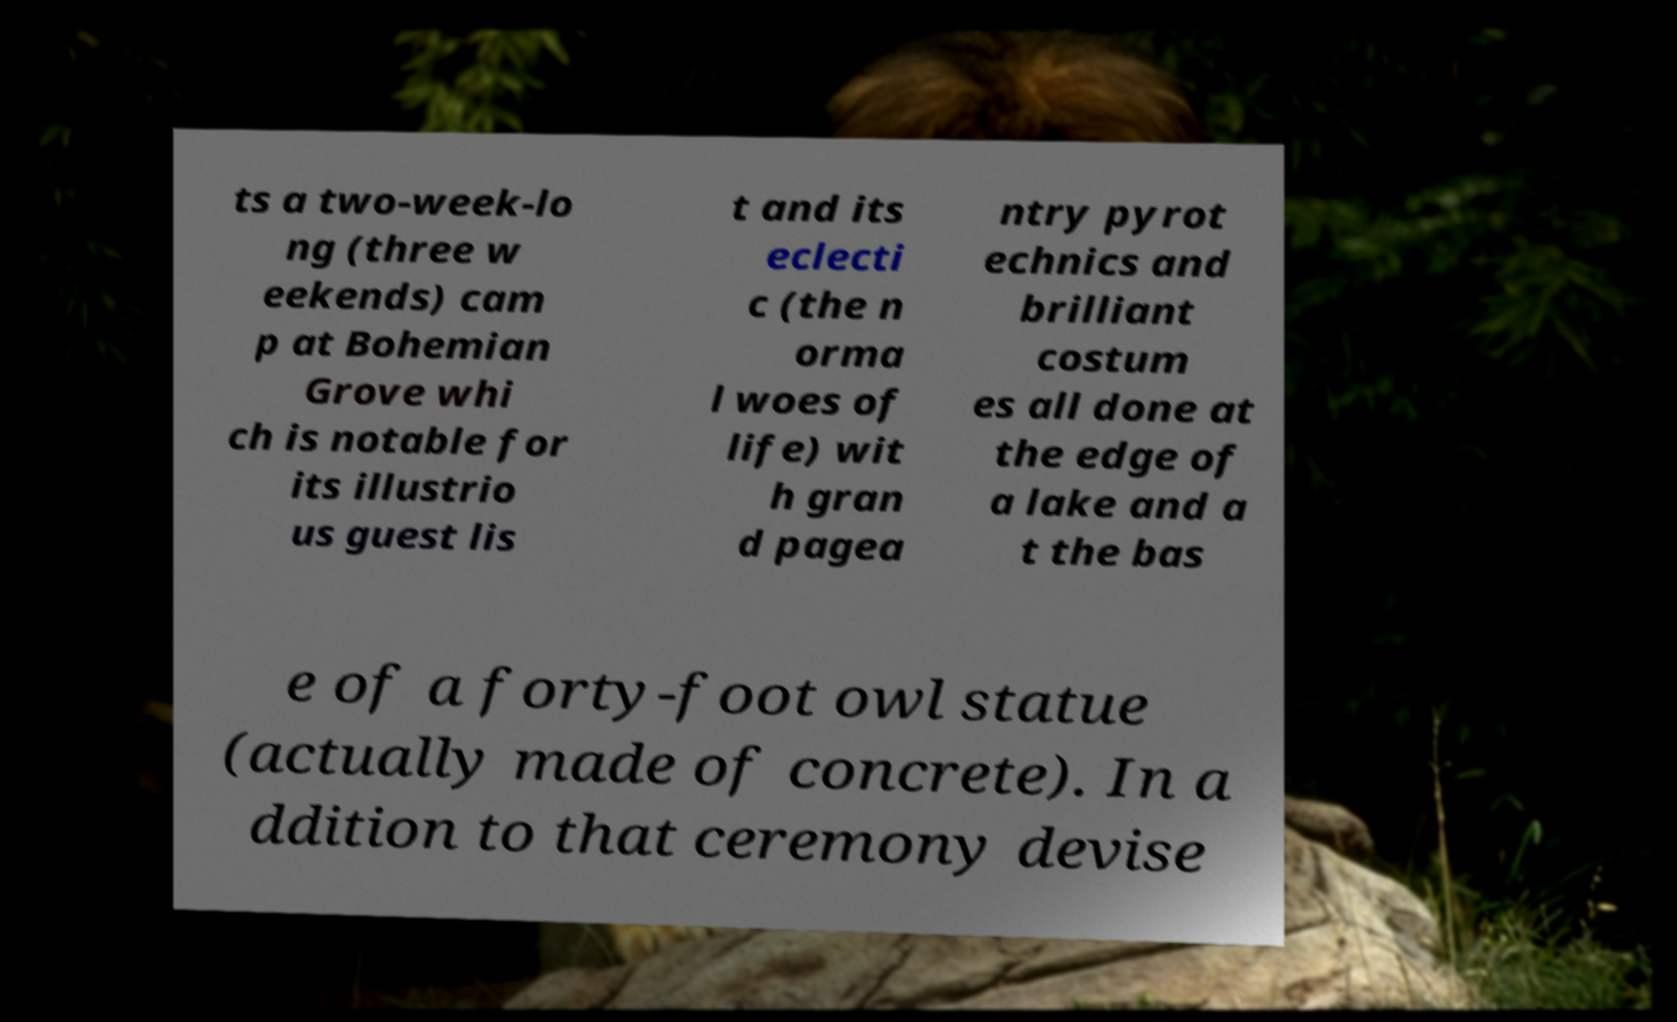For documentation purposes, I need the text within this image transcribed. Could you provide that? ts a two-week-lo ng (three w eekends) cam p at Bohemian Grove whi ch is notable for its illustrio us guest lis t and its eclecti c (the n orma l woes of life) wit h gran d pagea ntry pyrot echnics and brilliant costum es all done at the edge of a lake and a t the bas e of a forty-foot owl statue (actually made of concrete). In a ddition to that ceremony devise 